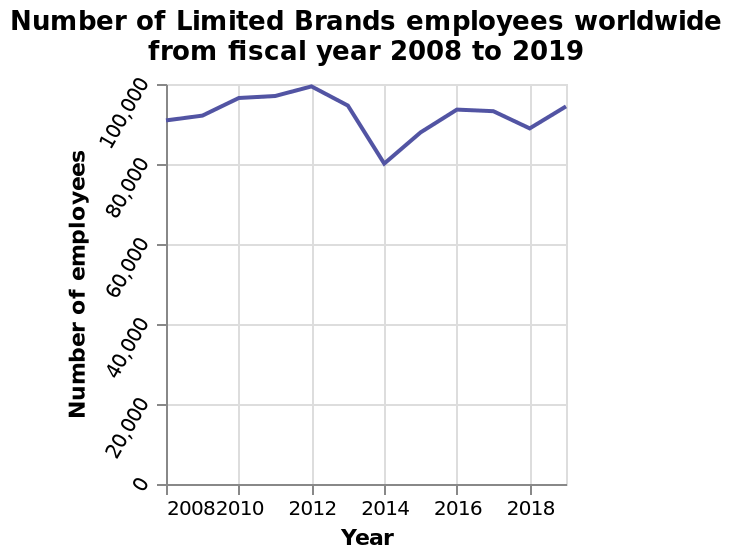<image>
What is the range of values shown on the y-axis? The range of values on the y-axis is from 0 to 100,000. What happened to the staff numbers during 2012 and 2014? The staff numbers increased in 2012 and declined in 2014. Was there an increase or decrease in staff during 2014?  There was a decrease in staff during 2014. 